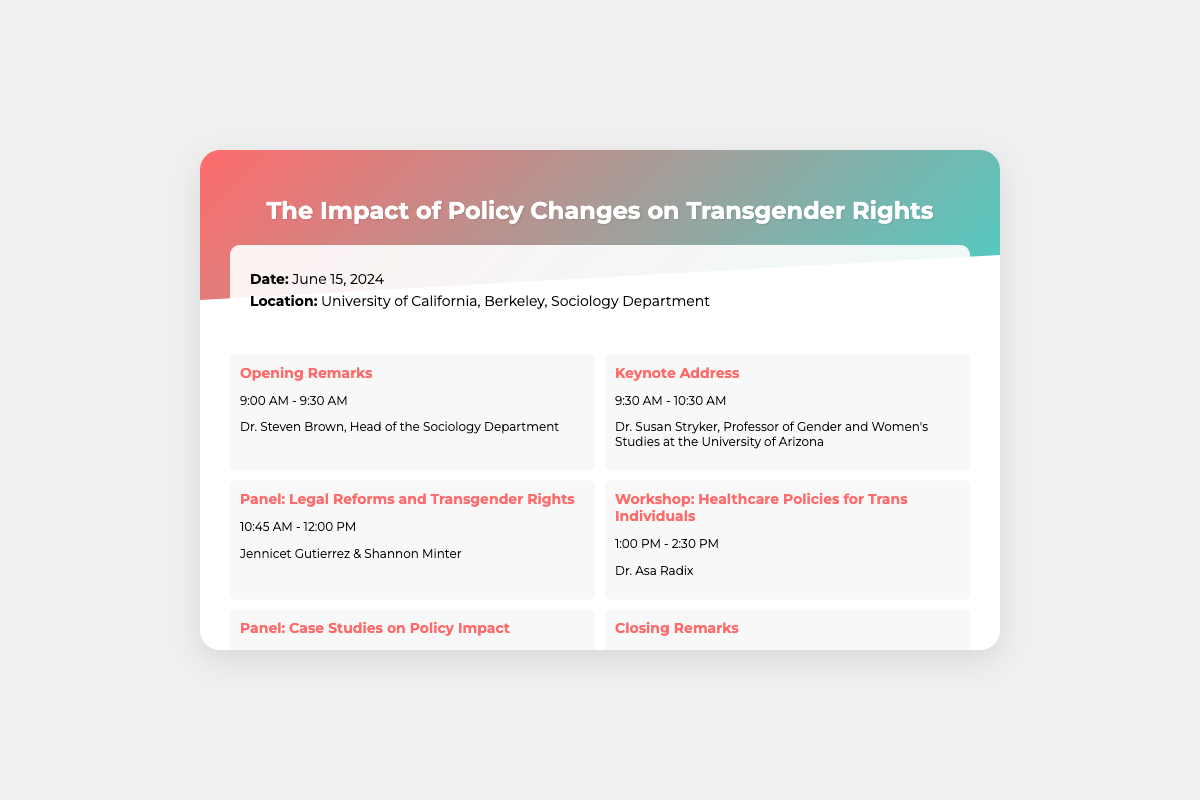What is the date of the conference? The date of the conference is explicitly stated in the details section of the document.
Answer: June 15, 2024 Who is giving the keynote address? The document lists the keynote speaker in the schedule section, along with their title and affiliation.
Answer: Dr. Susan Stryker What time does the panel on legal reforms begin? The schedule provides the start time for each event, including the panel on legal reforms.
Answer: 10:45 AM Where is the conference being held? The location is mentioned in the details section of the envelope.
Answer: University of California, Berkeley, Sociology Department How many schedule items are listed for the conference? By counting the number of schedule items in the document, the total can be determined.
Answer: Six Who is responsible for opening remarks? The document specifies the person delivering opening remarks under the schedule section.
Answer: Dr. Steven Brown What type of event follows the closing remarks? The schedule outlines the order of events, specifying which event follows closing remarks.
Answer: None What is the contact email provided for the conference? The contact information is detailed at the bottom of the document.
Answer: transrightsconference@berkeley.edu 